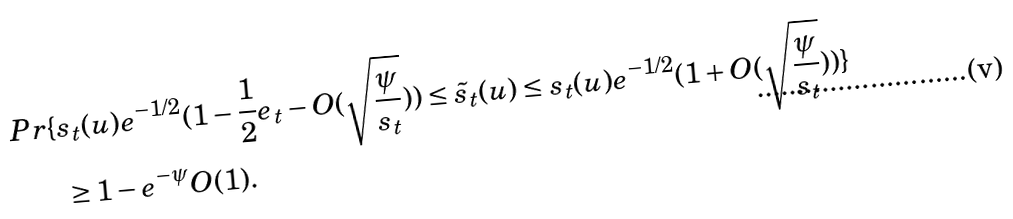Convert formula to latex. <formula><loc_0><loc_0><loc_500><loc_500>P r \{ & s _ { t } ( u ) e ^ { - 1 / 2 } ( 1 - \frac { 1 } { 2 } e _ { t } - O ( \sqrt { \frac { \psi } { s _ { t } } } ) ) \leq \tilde { s } _ { t } ( u ) \leq s _ { t } ( u ) e ^ { - 1 / 2 } ( 1 + O ( \sqrt { \frac { \psi } { s _ { t } } } ) ) \} \\ & \, \geq 1 - e ^ { - \psi } O ( 1 ) .</formula> 